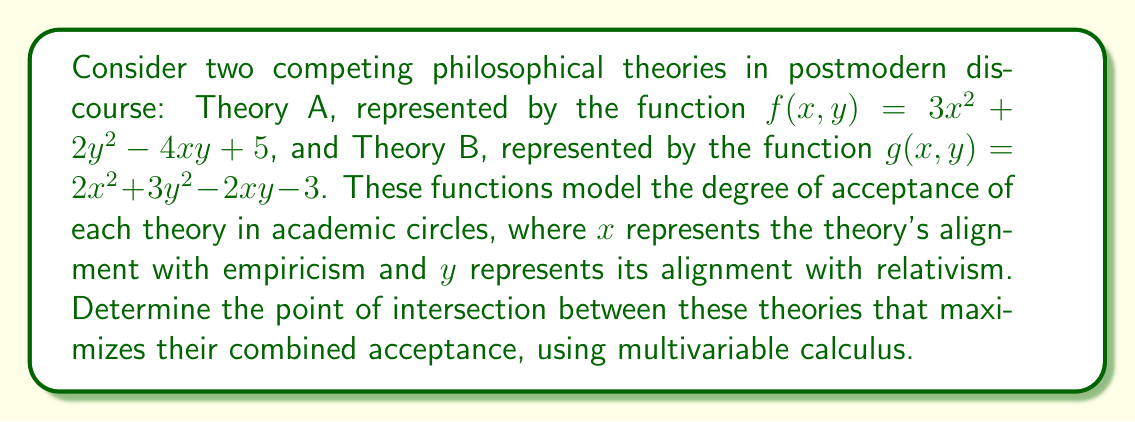What is the answer to this math problem? To solve this problem, we need to follow these steps:

1) First, we need to create a function that represents the combined acceptance of both theories. This can be done by adding the two functions:

   $h(x,y) = f(x,y) + g(x,y) = (3x^2 + 2y^2 - 4xy + 5) + (2x^2 + 3y^2 - 2xy - 3)$
   $h(x,y) = 5x^2 + 5y^2 - 6xy + 2$

2) To find the maximum point of this function, we need to find its critical points. We do this by taking partial derivatives with respect to x and y and setting them equal to zero:

   $\frac{\partial h}{\partial x} = 10x - 6y = 0$
   $\frac{\partial h}{\partial y} = 10y - 6x = 0$

3) Now we have a system of equations:

   $10x - 6y = 0$
   $-6x + 10y = 0$

4) We can solve this system using substitution or elimination. Let's use elimination:

   Multiply the first equation by 3 and the second by 5:
   
   $30x - 18y = 0$
   $-30x + 50y = 0$

   Adding these equations:
   
   $32y = 0$
   $y = 0$

   Substituting this back into $10x - 6y = 0$:
   
   $10x = 0$
   $x = 0$

5) To confirm this is a maximum and not a minimum, we can check the second partial derivatives:

   $\frac{\partial^2 h}{\partial x^2} = 10$
   $\frac{\partial^2 h}{\partial y^2} = 10$
   $\frac{\partial^2 h}{\partial x \partial y} = -6$

   The Hessian matrix is:
   $$H = \begin{bmatrix} 10 & -6 \\ -6 & 10 \end{bmatrix}$$

   The determinant of H is positive (64 > 0) and $\frac{\partial^2 h}{\partial x^2} > 0$, confirming this is a local maximum.

Therefore, the point (0,0) represents the optimal intersection of the two theories, maximizing their combined acceptance.
Answer: The optimal point of intersection between the two philosophical theories that maximizes their combined acceptance is (0,0). 